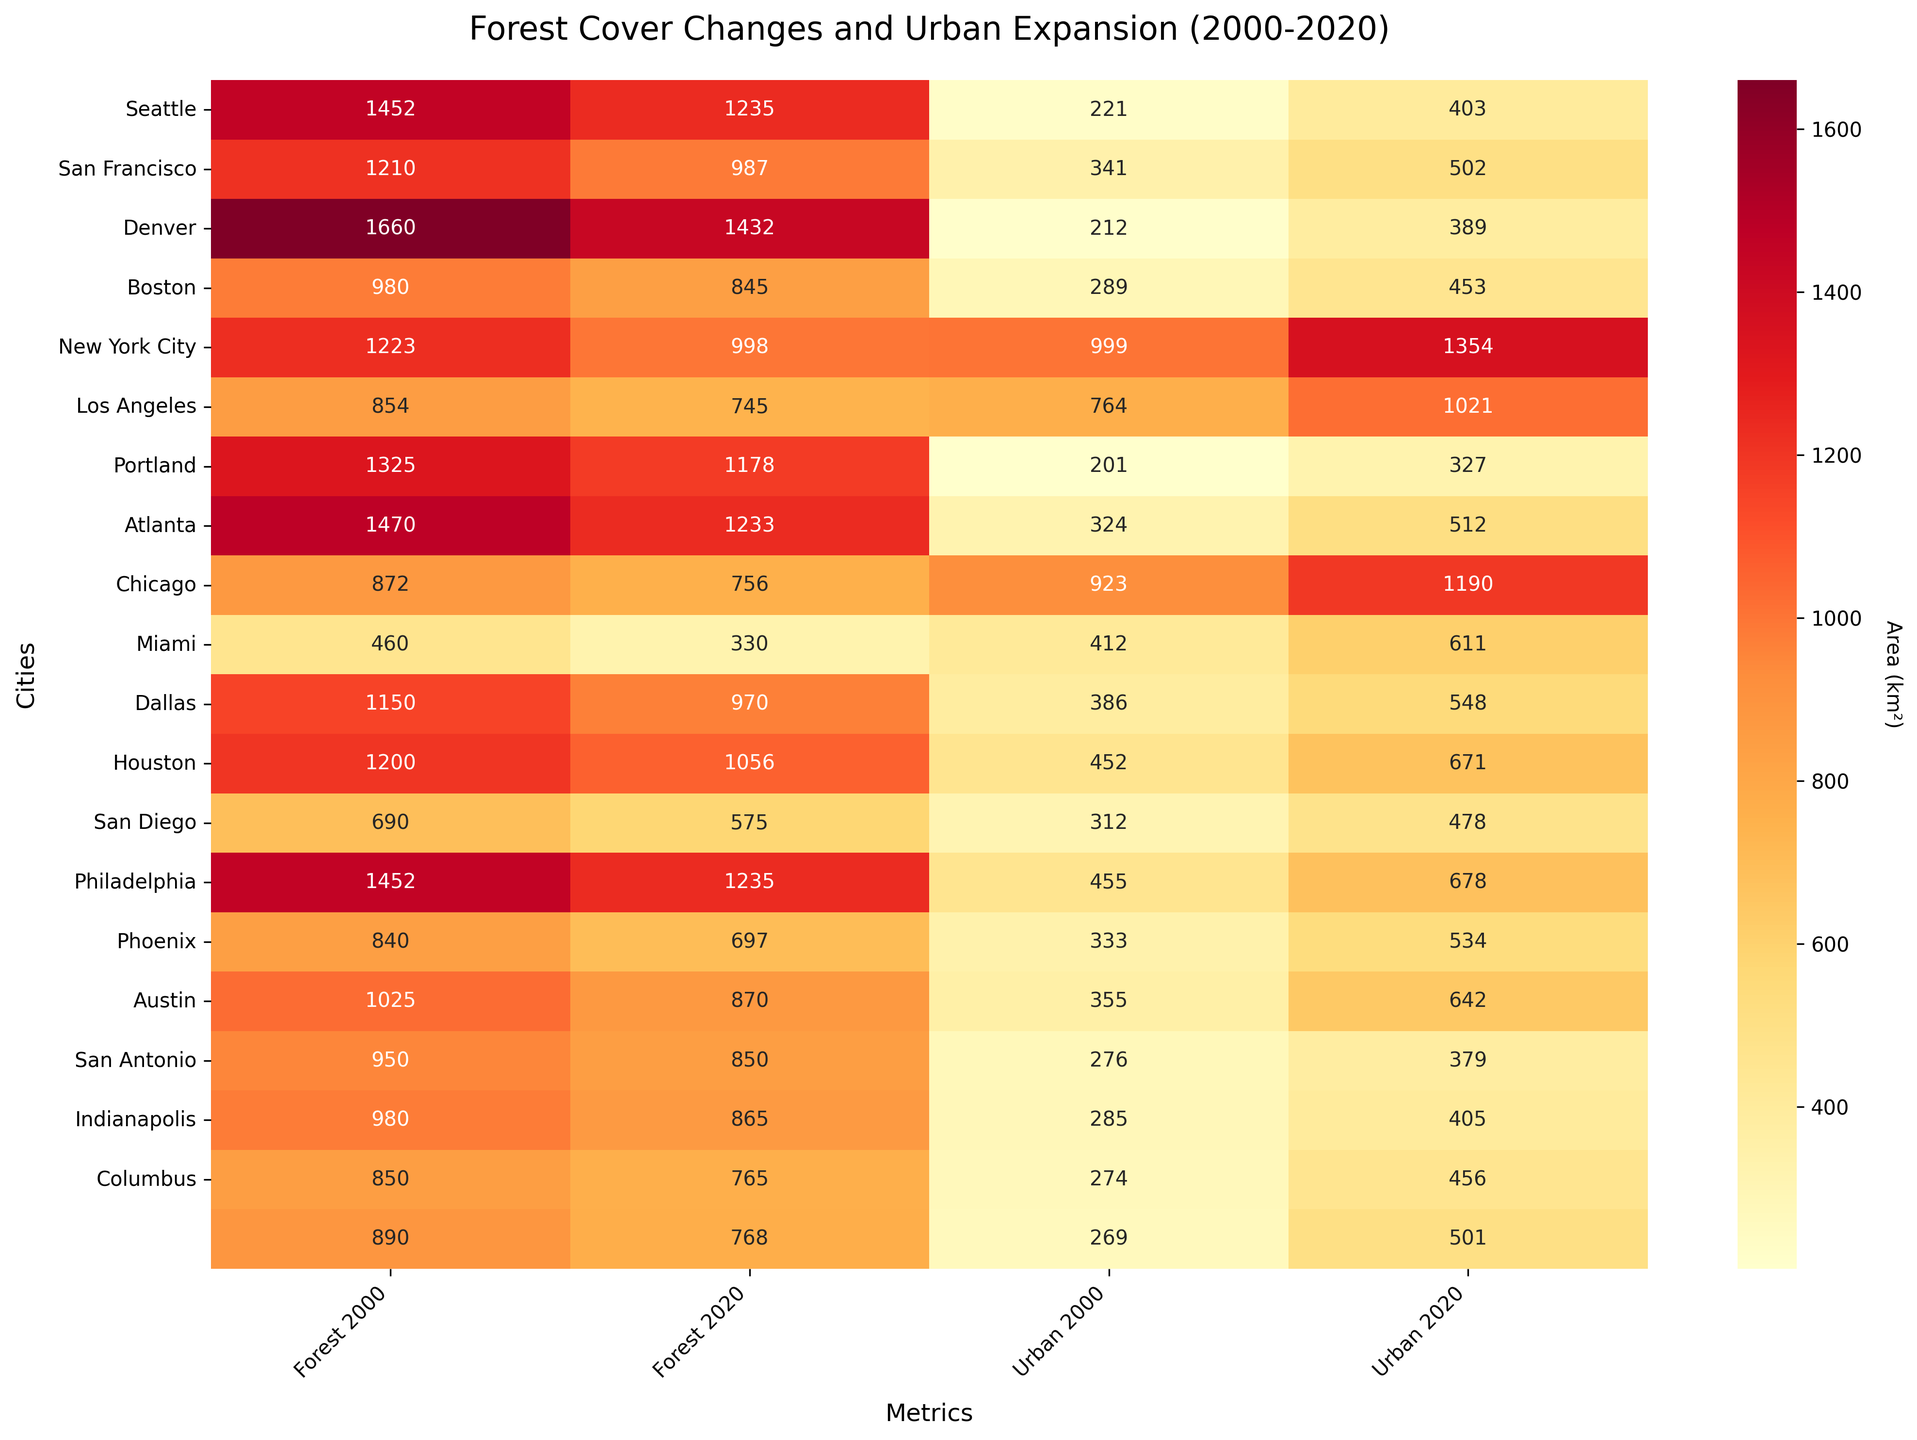What's the title of the heatmap? The title of a heatmap provides information about the broader context of the data. Here, it can be found at the top of the figure.
Answer: Forest Cover Changes and Urban Expansion (2000-2020) Which city had the largest decrease in forest area from 2000 to 2020? To find the largest decrease, subtract the 2020 forest area values from the 2000 values for each city and find the maximum value.
Answer: Miami How many cities are compared in this heatmap? The number of cities can be determined by counting the unique entries on the y-axis.
Answer: 20 What is the urban area of Dallas in 2020? The urban area of Dallas in 2020 can be identified by locating Dallas on the y-axis and checking the corresponding value under the 'Urban 2020' column.
Answer: 548 km² Which city had the smallest increase in urban area from 2000 to 2020? To determine the smallest increase, subtract the 2000 urban area values from the 2020 values for each city and find the minimum value.
Answer: Austin Which city had more forest area in 2020, Houston or Philadelphia? Compare the values in the 'Forest 2020' column for Houston and Philadelphia.
Answer: Houston What is the average forest area in 2020 for cities located on the West Coast (Seattle, San Francisco, Los Angeles, San Diego)? Sum the forest area values for Seattle, San Francisco, Los Angeles, and San Diego in 2020 and divide by 4.
Answer: (1235 + 987 + 745 + 575) / 4 = 1136.75 km² By how much did the urban area of New York City increase from 2000 to 2020? Subtract the 2000 urban area value for New York City from the 2020 value.
Answer: 1354 - 999 = 355 km² Which city had the largest urban area in 2000 and urban area in 2020? Compare values under the 'Urban 2000' and 'Urban 2020' columns to find the maximum in each.
Answer: New York City How can you describe the overall trend between urban expansion and deforestation across these cities? Urban areas have generally increased while forest areas have decreased, indicating a trend of urban expansion driving deforestation.
Answer: Urban expansion correlates with deforestation 